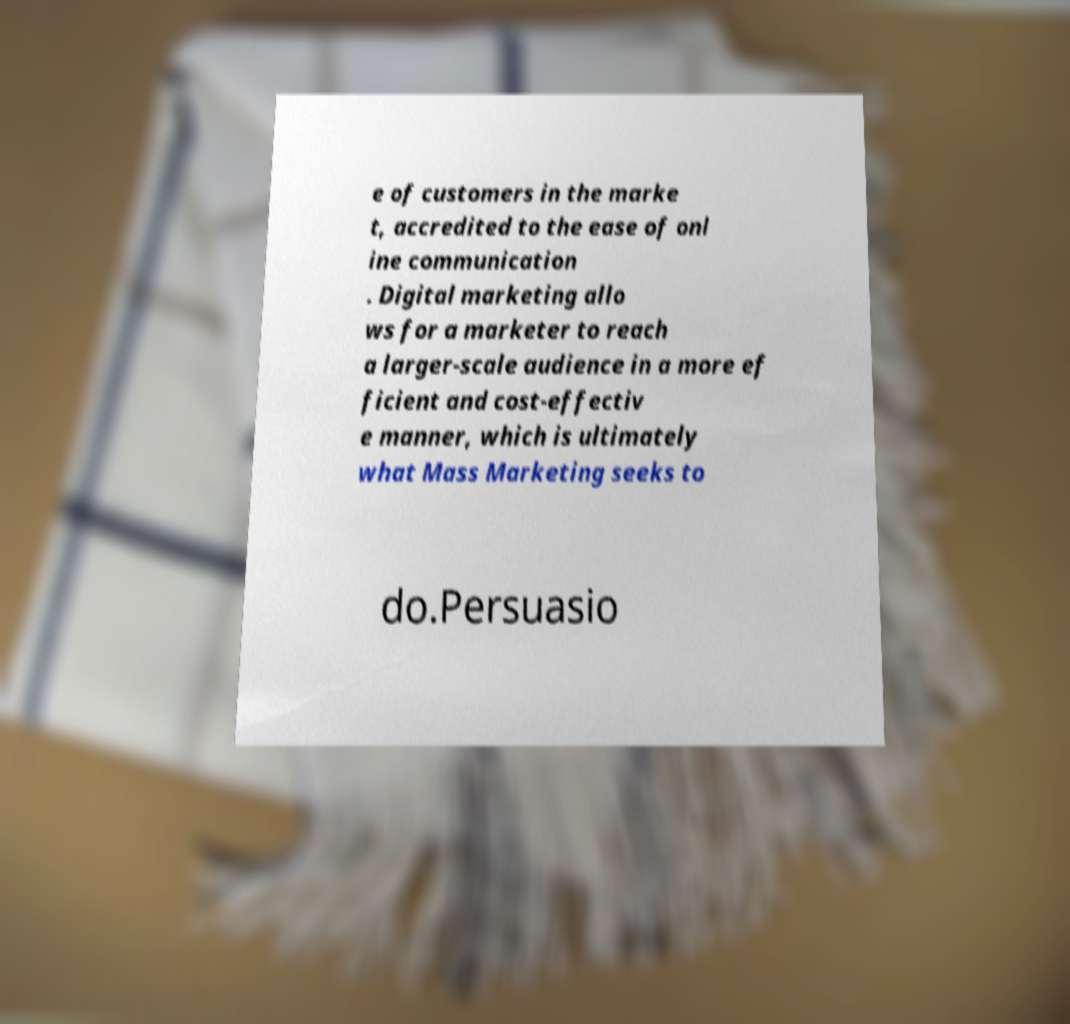Please read and relay the text visible in this image. What does it say? e of customers in the marke t, accredited to the ease of onl ine communication . Digital marketing allo ws for a marketer to reach a larger-scale audience in a more ef ficient and cost-effectiv e manner, which is ultimately what Mass Marketing seeks to do.Persuasio 